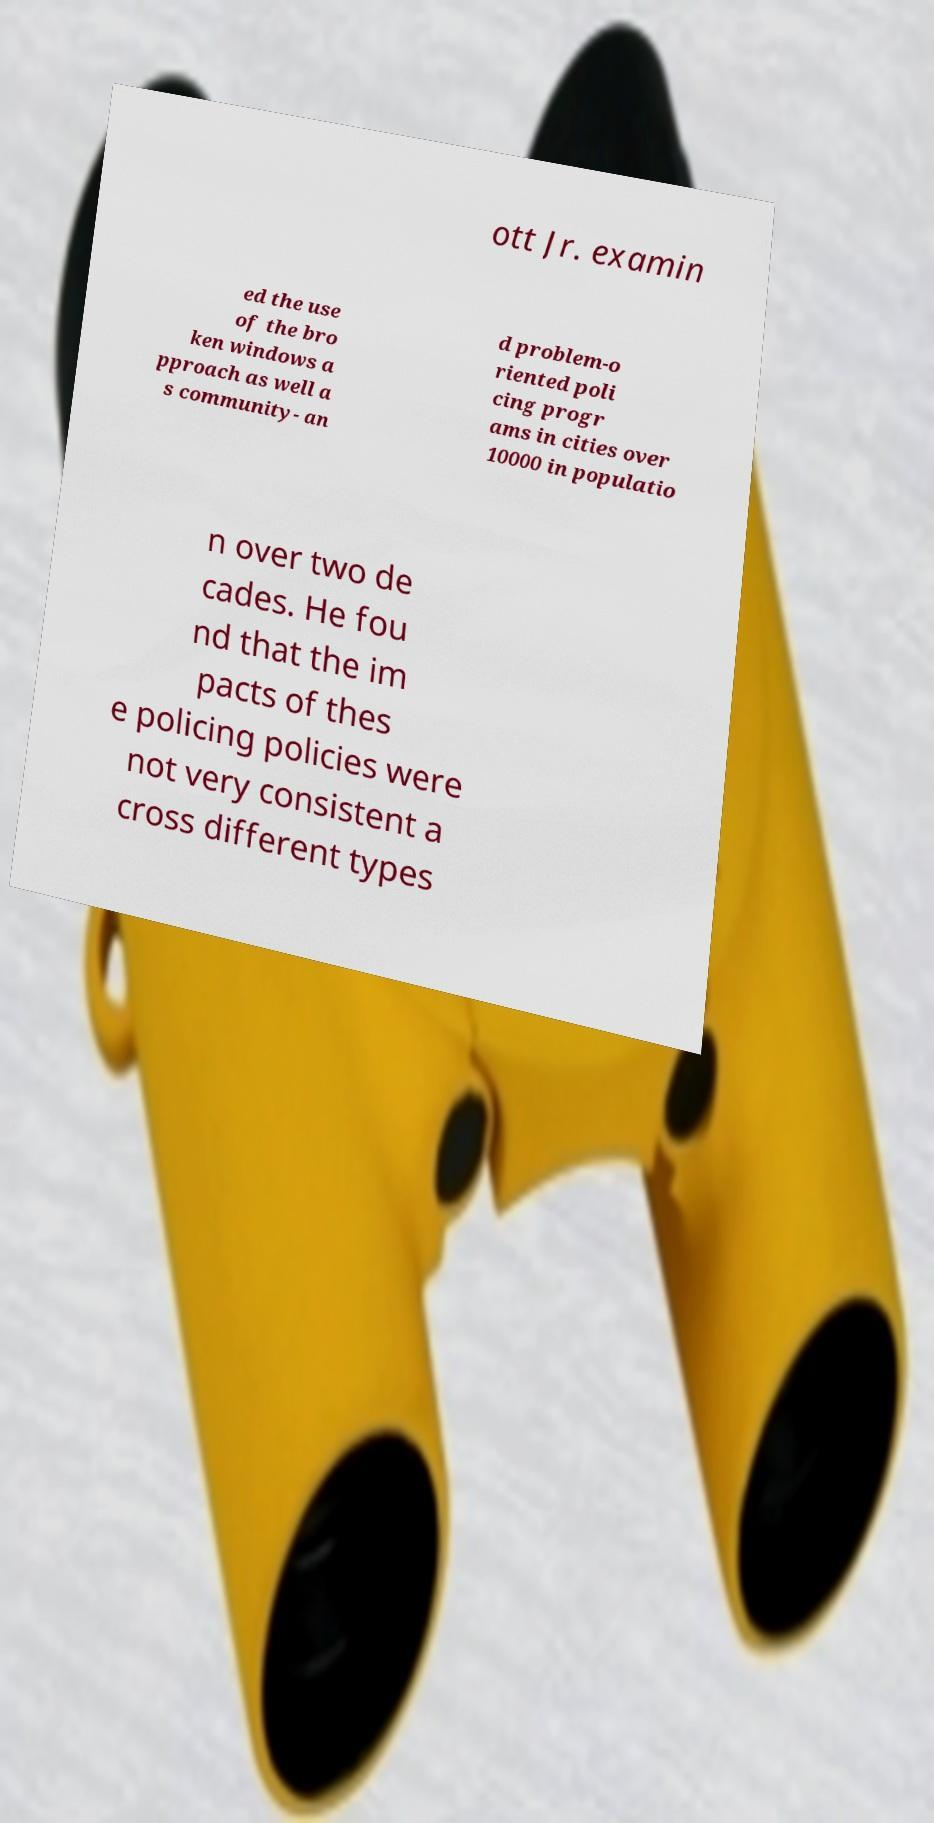Please read and relay the text visible in this image. What does it say? ott Jr. examin ed the use of the bro ken windows a pproach as well a s community- an d problem-o riented poli cing progr ams in cities over 10000 in populatio n over two de cades. He fou nd that the im pacts of thes e policing policies were not very consistent a cross different types 